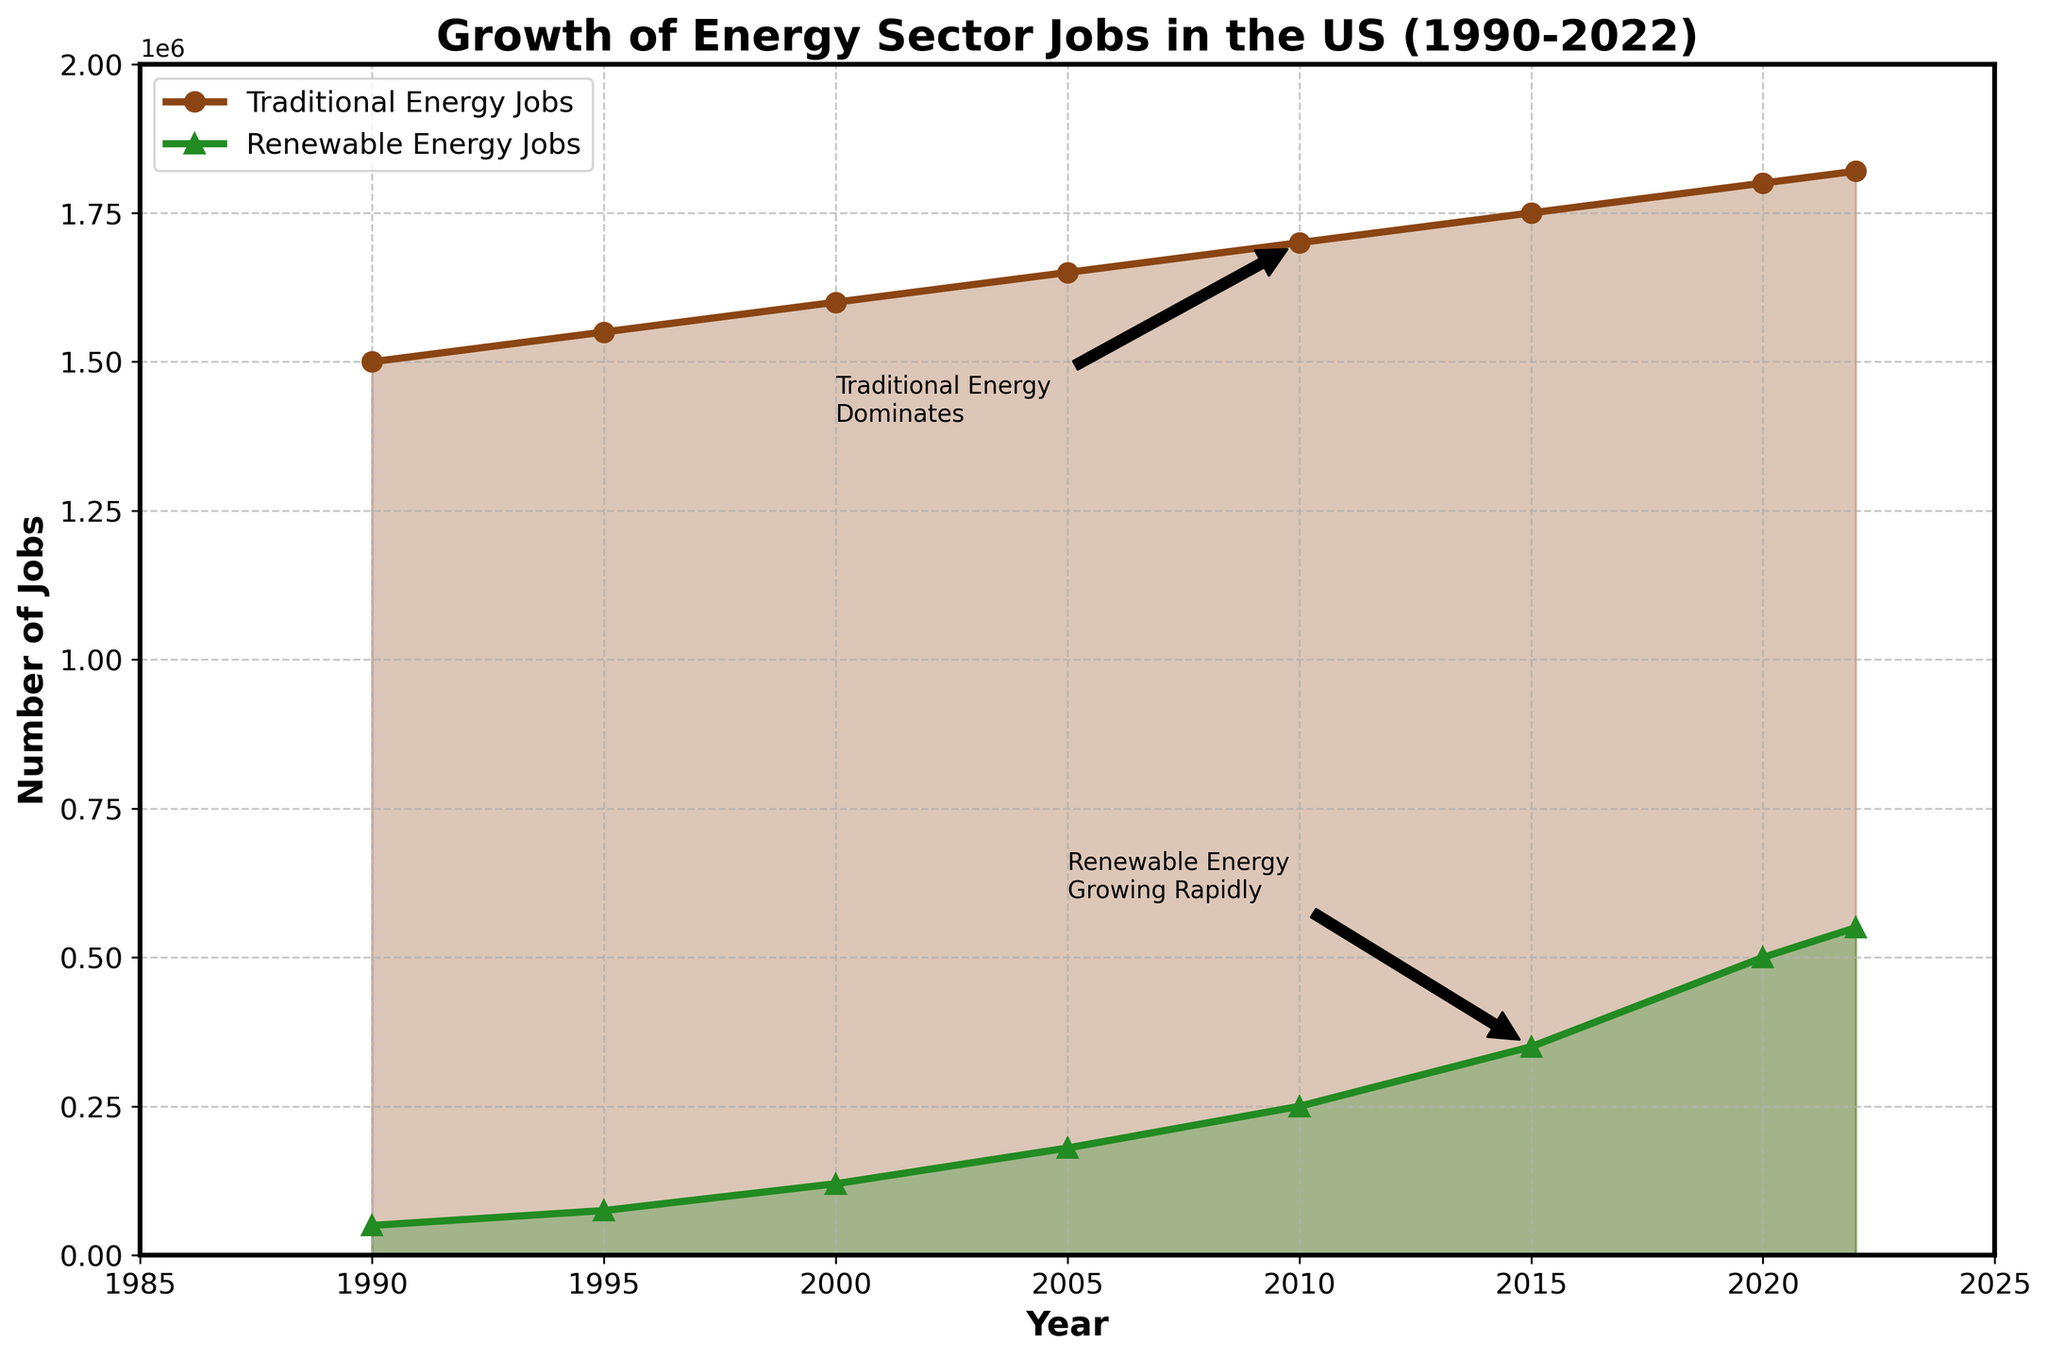What is the general trend of Traditional Energy Jobs from 1990 to 2022? The line representing Traditional Energy Jobs shows a steady upward trend over the period from 1990 to 2022, indicating growth.
Answer: Upward trend How many renewable energy jobs were there in 2020? According to the line chart, the number of renewable energy jobs in 2020 is marked on the graph as 500,000.
Answer: 500,000 How many more traditional energy jobs were there compared to renewable energy jobs in 2000? In 2000, there were 1,600,000 traditional energy jobs and 120,000 renewable energy jobs. The difference is 1,600,000 - 120,000 = 1,480,000.
Answer: 1,480,000 In which year did renewable energy jobs see the fastest growth rate, based on the slope of the line? The steepest slope in the renewable energy jobs line is observed between 2015 and 2020, indicating the fastest growth rate in this period.
Answer: 2015-2020 By how much did traditional energy jobs increase from 1990 to 2022? Traditional energy jobs in 1990 were 1,500,000 and in 2022 were 1,820,000. The increase is 1,820,000 - 1,500,000 = 320,000.
Answer: 320,000 What annotation appears near the traditional energy jobs line on the graph and what information does it convey? The annotation "Traditional Energy Dominates" appears near the traditional energy jobs line around 2010, indicating that traditional energy jobs significantly outnumber renewable energy jobs at that point.
Answer: Traditional Energy Dominates Compare the number of traditional energy jobs and renewable energy jobs in 2015. In 2015, traditional energy jobs were 1,750,000 and renewable energy jobs were 350,000. Traditional energy jobs are 5 times greater than renewable energy jobs (1,750,000 ÷ 350,000 = 5).
Answer: 5 times greater Looking at the lines, how does the growth rate of renewable energy jobs compare to that of traditional energy jobs? The line for renewable energy jobs increases more steeply than that for traditional energy jobs, indicating a higher growth rate for renewable energy jobs over the period.
Answer: Higher growth rate 